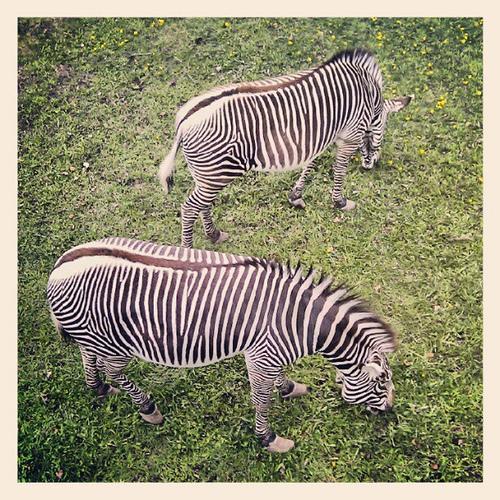How many zebras are there?
Give a very brief answer. 2. 